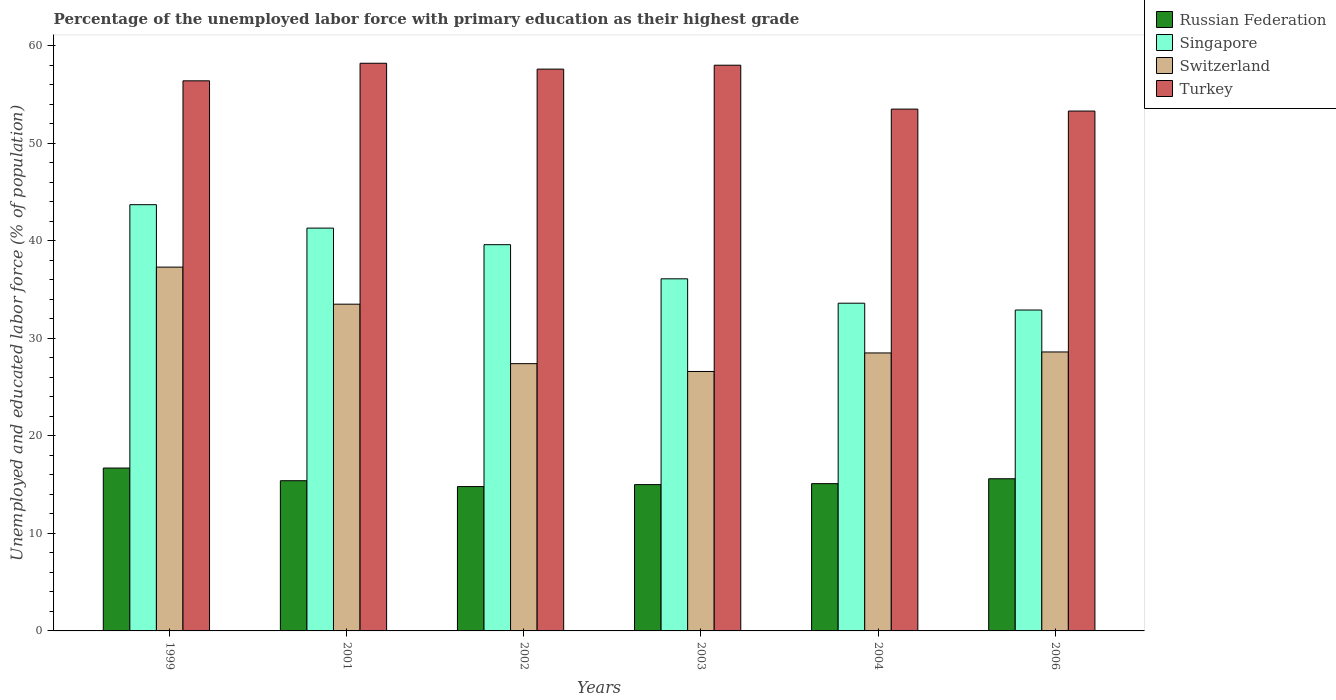How many bars are there on the 2nd tick from the left?
Your answer should be compact. 4. How many bars are there on the 3rd tick from the right?
Make the answer very short. 4. What is the percentage of the unemployed labor force with primary education in Russian Federation in 2001?
Offer a terse response. 15.4. Across all years, what is the maximum percentage of the unemployed labor force with primary education in Russian Federation?
Provide a short and direct response. 16.7. Across all years, what is the minimum percentage of the unemployed labor force with primary education in Switzerland?
Provide a succinct answer. 26.6. In which year was the percentage of the unemployed labor force with primary education in Switzerland maximum?
Your response must be concise. 1999. In which year was the percentage of the unemployed labor force with primary education in Singapore minimum?
Give a very brief answer. 2006. What is the total percentage of the unemployed labor force with primary education in Russian Federation in the graph?
Keep it short and to the point. 92.6. What is the difference between the percentage of the unemployed labor force with primary education in Turkey in 2001 and that in 2004?
Give a very brief answer. 4.7. What is the difference between the percentage of the unemployed labor force with primary education in Russian Federation in 2001 and the percentage of the unemployed labor force with primary education in Turkey in 2006?
Keep it short and to the point. -37.9. What is the average percentage of the unemployed labor force with primary education in Switzerland per year?
Provide a short and direct response. 30.32. In the year 2001, what is the difference between the percentage of the unemployed labor force with primary education in Russian Federation and percentage of the unemployed labor force with primary education in Turkey?
Make the answer very short. -42.8. In how many years, is the percentage of the unemployed labor force with primary education in Singapore greater than 50 %?
Provide a succinct answer. 0. What is the ratio of the percentage of the unemployed labor force with primary education in Turkey in 1999 to that in 2001?
Offer a very short reply. 0.97. Is the difference between the percentage of the unemployed labor force with primary education in Russian Federation in 2002 and 2003 greater than the difference between the percentage of the unemployed labor force with primary education in Turkey in 2002 and 2003?
Give a very brief answer. Yes. What is the difference between the highest and the second highest percentage of the unemployed labor force with primary education in Russian Federation?
Your answer should be compact. 1.1. What is the difference between the highest and the lowest percentage of the unemployed labor force with primary education in Turkey?
Offer a terse response. 4.9. In how many years, is the percentage of the unemployed labor force with primary education in Russian Federation greater than the average percentage of the unemployed labor force with primary education in Russian Federation taken over all years?
Provide a succinct answer. 2. Is the sum of the percentage of the unemployed labor force with primary education in Singapore in 2001 and 2002 greater than the maximum percentage of the unemployed labor force with primary education in Turkey across all years?
Provide a short and direct response. Yes. What does the 1st bar from the left in 2001 represents?
Offer a terse response. Russian Federation. What does the 4th bar from the right in 1999 represents?
Provide a short and direct response. Russian Federation. Is it the case that in every year, the sum of the percentage of the unemployed labor force with primary education in Russian Federation and percentage of the unemployed labor force with primary education in Switzerland is greater than the percentage of the unemployed labor force with primary education in Turkey?
Provide a succinct answer. No. How many bars are there?
Provide a succinct answer. 24. Are all the bars in the graph horizontal?
Provide a succinct answer. No. How many years are there in the graph?
Ensure brevity in your answer.  6. Does the graph contain grids?
Your answer should be very brief. No. Where does the legend appear in the graph?
Your answer should be very brief. Top right. How are the legend labels stacked?
Your answer should be very brief. Vertical. What is the title of the graph?
Offer a very short reply. Percentage of the unemployed labor force with primary education as their highest grade. What is the label or title of the X-axis?
Give a very brief answer. Years. What is the label or title of the Y-axis?
Give a very brief answer. Unemployed and educated labor force (% of population). What is the Unemployed and educated labor force (% of population) in Russian Federation in 1999?
Offer a terse response. 16.7. What is the Unemployed and educated labor force (% of population) in Singapore in 1999?
Make the answer very short. 43.7. What is the Unemployed and educated labor force (% of population) of Switzerland in 1999?
Offer a very short reply. 37.3. What is the Unemployed and educated labor force (% of population) of Turkey in 1999?
Keep it short and to the point. 56.4. What is the Unemployed and educated labor force (% of population) in Russian Federation in 2001?
Ensure brevity in your answer.  15.4. What is the Unemployed and educated labor force (% of population) of Singapore in 2001?
Your answer should be very brief. 41.3. What is the Unemployed and educated labor force (% of population) of Switzerland in 2001?
Offer a terse response. 33.5. What is the Unemployed and educated labor force (% of population) of Turkey in 2001?
Ensure brevity in your answer.  58.2. What is the Unemployed and educated labor force (% of population) in Russian Federation in 2002?
Keep it short and to the point. 14.8. What is the Unemployed and educated labor force (% of population) of Singapore in 2002?
Ensure brevity in your answer.  39.6. What is the Unemployed and educated labor force (% of population) in Switzerland in 2002?
Give a very brief answer. 27.4. What is the Unemployed and educated labor force (% of population) in Turkey in 2002?
Offer a terse response. 57.6. What is the Unemployed and educated labor force (% of population) of Russian Federation in 2003?
Keep it short and to the point. 15. What is the Unemployed and educated labor force (% of population) of Singapore in 2003?
Your answer should be compact. 36.1. What is the Unemployed and educated labor force (% of population) in Switzerland in 2003?
Provide a short and direct response. 26.6. What is the Unemployed and educated labor force (% of population) of Russian Federation in 2004?
Offer a very short reply. 15.1. What is the Unemployed and educated labor force (% of population) in Singapore in 2004?
Offer a terse response. 33.6. What is the Unemployed and educated labor force (% of population) of Turkey in 2004?
Make the answer very short. 53.5. What is the Unemployed and educated labor force (% of population) of Russian Federation in 2006?
Your answer should be compact. 15.6. What is the Unemployed and educated labor force (% of population) in Singapore in 2006?
Your answer should be compact. 32.9. What is the Unemployed and educated labor force (% of population) of Switzerland in 2006?
Your response must be concise. 28.6. What is the Unemployed and educated labor force (% of population) of Turkey in 2006?
Provide a succinct answer. 53.3. Across all years, what is the maximum Unemployed and educated labor force (% of population) of Russian Federation?
Provide a succinct answer. 16.7. Across all years, what is the maximum Unemployed and educated labor force (% of population) of Singapore?
Ensure brevity in your answer.  43.7. Across all years, what is the maximum Unemployed and educated labor force (% of population) of Switzerland?
Provide a short and direct response. 37.3. Across all years, what is the maximum Unemployed and educated labor force (% of population) of Turkey?
Offer a very short reply. 58.2. Across all years, what is the minimum Unemployed and educated labor force (% of population) of Russian Federation?
Your answer should be compact. 14.8. Across all years, what is the minimum Unemployed and educated labor force (% of population) in Singapore?
Provide a succinct answer. 32.9. Across all years, what is the minimum Unemployed and educated labor force (% of population) of Switzerland?
Give a very brief answer. 26.6. Across all years, what is the minimum Unemployed and educated labor force (% of population) in Turkey?
Offer a very short reply. 53.3. What is the total Unemployed and educated labor force (% of population) in Russian Federation in the graph?
Provide a succinct answer. 92.6. What is the total Unemployed and educated labor force (% of population) of Singapore in the graph?
Provide a succinct answer. 227.2. What is the total Unemployed and educated labor force (% of population) in Switzerland in the graph?
Keep it short and to the point. 181.9. What is the total Unemployed and educated labor force (% of population) in Turkey in the graph?
Make the answer very short. 337. What is the difference between the Unemployed and educated labor force (% of population) of Russian Federation in 1999 and that in 2001?
Keep it short and to the point. 1.3. What is the difference between the Unemployed and educated labor force (% of population) of Singapore in 1999 and that in 2001?
Make the answer very short. 2.4. What is the difference between the Unemployed and educated labor force (% of population) in Switzerland in 1999 and that in 2001?
Offer a terse response. 3.8. What is the difference between the Unemployed and educated labor force (% of population) in Turkey in 1999 and that in 2001?
Your answer should be compact. -1.8. What is the difference between the Unemployed and educated labor force (% of population) in Russian Federation in 1999 and that in 2002?
Ensure brevity in your answer.  1.9. What is the difference between the Unemployed and educated labor force (% of population) of Turkey in 1999 and that in 2002?
Make the answer very short. -1.2. What is the difference between the Unemployed and educated labor force (% of population) in Singapore in 1999 and that in 2003?
Your answer should be compact. 7.6. What is the difference between the Unemployed and educated labor force (% of population) in Turkey in 1999 and that in 2003?
Your response must be concise. -1.6. What is the difference between the Unemployed and educated labor force (% of population) in Switzerland in 1999 and that in 2004?
Ensure brevity in your answer.  8.8. What is the difference between the Unemployed and educated labor force (% of population) in Russian Federation in 1999 and that in 2006?
Keep it short and to the point. 1.1. What is the difference between the Unemployed and educated labor force (% of population) of Singapore in 1999 and that in 2006?
Provide a succinct answer. 10.8. What is the difference between the Unemployed and educated labor force (% of population) of Switzerland in 1999 and that in 2006?
Provide a short and direct response. 8.7. What is the difference between the Unemployed and educated labor force (% of population) of Turkey in 1999 and that in 2006?
Your response must be concise. 3.1. What is the difference between the Unemployed and educated labor force (% of population) of Russian Federation in 2001 and that in 2002?
Keep it short and to the point. 0.6. What is the difference between the Unemployed and educated labor force (% of population) in Singapore in 2001 and that in 2002?
Your response must be concise. 1.7. What is the difference between the Unemployed and educated labor force (% of population) in Russian Federation in 2001 and that in 2003?
Give a very brief answer. 0.4. What is the difference between the Unemployed and educated labor force (% of population) of Switzerland in 2001 and that in 2003?
Make the answer very short. 6.9. What is the difference between the Unemployed and educated labor force (% of population) of Russian Federation in 2001 and that in 2004?
Ensure brevity in your answer.  0.3. What is the difference between the Unemployed and educated labor force (% of population) in Singapore in 2001 and that in 2004?
Offer a terse response. 7.7. What is the difference between the Unemployed and educated labor force (% of population) in Switzerland in 2001 and that in 2004?
Your response must be concise. 5. What is the difference between the Unemployed and educated labor force (% of population) in Russian Federation in 2001 and that in 2006?
Give a very brief answer. -0.2. What is the difference between the Unemployed and educated labor force (% of population) of Singapore in 2001 and that in 2006?
Your response must be concise. 8.4. What is the difference between the Unemployed and educated labor force (% of population) in Turkey in 2001 and that in 2006?
Offer a terse response. 4.9. What is the difference between the Unemployed and educated labor force (% of population) of Russian Federation in 2002 and that in 2003?
Your answer should be very brief. -0.2. What is the difference between the Unemployed and educated labor force (% of population) of Singapore in 2002 and that in 2003?
Offer a very short reply. 3.5. What is the difference between the Unemployed and educated labor force (% of population) of Switzerland in 2002 and that in 2003?
Offer a very short reply. 0.8. What is the difference between the Unemployed and educated labor force (% of population) of Turkey in 2002 and that in 2003?
Provide a succinct answer. -0.4. What is the difference between the Unemployed and educated labor force (% of population) of Russian Federation in 2002 and that in 2004?
Give a very brief answer. -0.3. What is the difference between the Unemployed and educated labor force (% of population) of Singapore in 2002 and that in 2004?
Provide a short and direct response. 6. What is the difference between the Unemployed and educated labor force (% of population) of Switzerland in 2002 and that in 2004?
Your answer should be very brief. -1.1. What is the difference between the Unemployed and educated labor force (% of population) in Turkey in 2002 and that in 2004?
Offer a very short reply. 4.1. What is the difference between the Unemployed and educated labor force (% of population) in Russian Federation in 2002 and that in 2006?
Your response must be concise. -0.8. What is the difference between the Unemployed and educated labor force (% of population) of Singapore in 2002 and that in 2006?
Give a very brief answer. 6.7. What is the difference between the Unemployed and educated labor force (% of population) of Russian Federation in 2003 and that in 2004?
Make the answer very short. -0.1. What is the difference between the Unemployed and educated labor force (% of population) of Singapore in 2003 and that in 2004?
Provide a succinct answer. 2.5. What is the difference between the Unemployed and educated labor force (% of population) in Switzerland in 2003 and that in 2004?
Keep it short and to the point. -1.9. What is the difference between the Unemployed and educated labor force (% of population) of Turkey in 2003 and that in 2004?
Your answer should be very brief. 4.5. What is the difference between the Unemployed and educated labor force (% of population) of Russian Federation in 2003 and that in 2006?
Give a very brief answer. -0.6. What is the difference between the Unemployed and educated labor force (% of population) of Switzerland in 2003 and that in 2006?
Ensure brevity in your answer.  -2. What is the difference between the Unemployed and educated labor force (% of population) in Switzerland in 2004 and that in 2006?
Ensure brevity in your answer.  -0.1. What is the difference between the Unemployed and educated labor force (% of population) of Russian Federation in 1999 and the Unemployed and educated labor force (% of population) of Singapore in 2001?
Keep it short and to the point. -24.6. What is the difference between the Unemployed and educated labor force (% of population) in Russian Federation in 1999 and the Unemployed and educated labor force (% of population) in Switzerland in 2001?
Keep it short and to the point. -16.8. What is the difference between the Unemployed and educated labor force (% of population) of Russian Federation in 1999 and the Unemployed and educated labor force (% of population) of Turkey in 2001?
Ensure brevity in your answer.  -41.5. What is the difference between the Unemployed and educated labor force (% of population) of Singapore in 1999 and the Unemployed and educated labor force (% of population) of Switzerland in 2001?
Ensure brevity in your answer.  10.2. What is the difference between the Unemployed and educated labor force (% of population) of Switzerland in 1999 and the Unemployed and educated labor force (% of population) of Turkey in 2001?
Your response must be concise. -20.9. What is the difference between the Unemployed and educated labor force (% of population) of Russian Federation in 1999 and the Unemployed and educated labor force (% of population) of Singapore in 2002?
Your answer should be compact. -22.9. What is the difference between the Unemployed and educated labor force (% of population) of Russian Federation in 1999 and the Unemployed and educated labor force (% of population) of Switzerland in 2002?
Keep it short and to the point. -10.7. What is the difference between the Unemployed and educated labor force (% of population) in Russian Federation in 1999 and the Unemployed and educated labor force (% of population) in Turkey in 2002?
Give a very brief answer. -40.9. What is the difference between the Unemployed and educated labor force (% of population) of Switzerland in 1999 and the Unemployed and educated labor force (% of population) of Turkey in 2002?
Provide a succinct answer. -20.3. What is the difference between the Unemployed and educated labor force (% of population) in Russian Federation in 1999 and the Unemployed and educated labor force (% of population) in Singapore in 2003?
Your answer should be compact. -19.4. What is the difference between the Unemployed and educated labor force (% of population) of Russian Federation in 1999 and the Unemployed and educated labor force (% of population) of Switzerland in 2003?
Make the answer very short. -9.9. What is the difference between the Unemployed and educated labor force (% of population) of Russian Federation in 1999 and the Unemployed and educated labor force (% of population) of Turkey in 2003?
Give a very brief answer. -41.3. What is the difference between the Unemployed and educated labor force (% of population) in Singapore in 1999 and the Unemployed and educated labor force (% of population) in Switzerland in 2003?
Your response must be concise. 17.1. What is the difference between the Unemployed and educated labor force (% of population) in Singapore in 1999 and the Unemployed and educated labor force (% of population) in Turkey in 2003?
Keep it short and to the point. -14.3. What is the difference between the Unemployed and educated labor force (% of population) of Switzerland in 1999 and the Unemployed and educated labor force (% of population) of Turkey in 2003?
Provide a succinct answer. -20.7. What is the difference between the Unemployed and educated labor force (% of population) of Russian Federation in 1999 and the Unemployed and educated labor force (% of population) of Singapore in 2004?
Give a very brief answer. -16.9. What is the difference between the Unemployed and educated labor force (% of population) of Russian Federation in 1999 and the Unemployed and educated labor force (% of population) of Turkey in 2004?
Your answer should be compact. -36.8. What is the difference between the Unemployed and educated labor force (% of population) of Singapore in 1999 and the Unemployed and educated labor force (% of population) of Switzerland in 2004?
Provide a short and direct response. 15.2. What is the difference between the Unemployed and educated labor force (% of population) in Singapore in 1999 and the Unemployed and educated labor force (% of population) in Turkey in 2004?
Offer a terse response. -9.8. What is the difference between the Unemployed and educated labor force (% of population) of Switzerland in 1999 and the Unemployed and educated labor force (% of population) of Turkey in 2004?
Your response must be concise. -16.2. What is the difference between the Unemployed and educated labor force (% of population) of Russian Federation in 1999 and the Unemployed and educated labor force (% of population) of Singapore in 2006?
Your response must be concise. -16.2. What is the difference between the Unemployed and educated labor force (% of population) of Russian Federation in 1999 and the Unemployed and educated labor force (% of population) of Turkey in 2006?
Ensure brevity in your answer.  -36.6. What is the difference between the Unemployed and educated labor force (% of population) of Singapore in 1999 and the Unemployed and educated labor force (% of population) of Switzerland in 2006?
Give a very brief answer. 15.1. What is the difference between the Unemployed and educated labor force (% of population) of Singapore in 1999 and the Unemployed and educated labor force (% of population) of Turkey in 2006?
Provide a short and direct response. -9.6. What is the difference between the Unemployed and educated labor force (% of population) in Switzerland in 1999 and the Unemployed and educated labor force (% of population) in Turkey in 2006?
Make the answer very short. -16. What is the difference between the Unemployed and educated labor force (% of population) in Russian Federation in 2001 and the Unemployed and educated labor force (% of population) in Singapore in 2002?
Your answer should be very brief. -24.2. What is the difference between the Unemployed and educated labor force (% of population) in Russian Federation in 2001 and the Unemployed and educated labor force (% of population) in Switzerland in 2002?
Offer a terse response. -12. What is the difference between the Unemployed and educated labor force (% of population) in Russian Federation in 2001 and the Unemployed and educated labor force (% of population) in Turkey in 2002?
Your response must be concise. -42.2. What is the difference between the Unemployed and educated labor force (% of population) of Singapore in 2001 and the Unemployed and educated labor force (% of population) of Turkey in 2002?
Make the answer very short. -16.3. What is the difference between the Unemployed and educated labor force (% of population) of Switzerland in 2001 and the Unemployed and educated labor force (% of population) of Turkey in 2002?
Provide a short and direct response. -24.1. What is the difference between the Unemployed and educated labor force (% of population) of Russian Federation in 2001 and the Unemployed and educated labor force (% of population) of Singapore in 2003?
Give a very brief answer. -20.7. What is the difference between the Unemployed and educated labor force (% of population) of Russian Federation in 2001 and the Unemployed and educated labor force (% of population) of Switzerland in 2003?
Offer a very short reply. -11.2. What is the difference between the Unemployed and educated labor force (% of population) in Russian Federation in 2001 and the Unemployed and educated labor force (% of population) in Turkey in 2003?
Your answer should be compact. -42.6. What is the difference between the Unemployed and educated labor force (% of population) in Singapore in 2001 and the Unemployed and educated labor force (% of population) in Switzerland in 2003?
Offer a terse response. 14.7. What is the difference between the Unemployed and educated labor force (% of population) in Singapore in 2001 and the Unemployed and educated labor force (% of population) in Turkey in 2003?
Your answer should be compact. -16.7. What is the difference between the Unemployed and educated labor force (% of population) of Switzerland in 2001 and the Unemployed and educated labor force (% of population) of Turkey in 2003?
Ensure brevity in your answer.  -24.5. What is the difference between the Unemployed and educated labor force (% of population) of Russian Federation in 2001 and the Unemployed and educated labor force (% of population) of Singapore in 2004?
Make the answer very short. -18.2. What is the difference between the Unemployed and educated labor force (% of population) of Russian Federation in 2001 and the Unemployed and educated labor force (% of population) of Switzerland in 2004?
Make the answer very short. -13.1. What is the difference between the Unemployed and educated labor force (% of population) of Russian Federation in 2001 and the Unemployed and educated labor force (% of population) of Turkey in 2004?
Your response must be concise. -38.1. What is the difference between the Unemployed and educated labor force (% of population) in Switzerland in 2001 and the Unemployed and educated labor force (% of population) in Turkey in 2004?
Ensure brevity in your answer.  -20. What is the difference between the Unemployed and educated labor force (% of population) of Russian Federation in 2001 and the Unemployed and educated labor force (% of population) of Singapore in 2006?
Provide a succinct answer. -17.5. What is the difference between the Unemployed and educated labor force (% of population) in Russian Federation in 2001 and the Unemployed and educated labor force (% of population) in Switzerland in 2006?
Provide a succinct answer. -13.2. What is the difference between the Unemployed and educated labor force (% of population) in Russian Federation in 2001 and the Unemployed and educated labor force (% of population) in Turkey in 2006?
Keep it short and to the point. -37.9. What is the difference between the Unemployed and educated labor force (% of population) of Singapore in 2001 and the Unemployed and educated labor force (% of population) of Switzerland in 2006?
Offer a very short reply. 12.7. What is the difference between the Unemployed and educated labor force (% of population) of Switzerland in 2001 and the Unemployed and educated labor force (% of population) of Turkey in 2006?
Provide a succinct answer. -19.8. What is the difference between the Unemployed and educated labor force (% of population) in Russian Federation in 2002 and the Unemployed and educated labor force (% of population) in Singapore in 2003?
Provide a short and direct response. -21.3. What is the difference between the Unemployed and educated labor force (% of population) of Russian Federation in 2002 and the Unemployed and educated labor force (% of population) of Switzerland in 2003?
Ensure brevity in your answer.  -11.8. What is the difference between the Unemployed and educated labor force (% of population) of Russian Federation in 2002 and the Unemployed and educated labor force (% of population) of Turkey in 2003?
Your answer should be very brief. -43.2. What is the difference between the Unemployed and educated labor force (% of population) of Singapore in 2002 and the Unemployed and educated labor force (% of population) of Switzerland in 2003?
Provide a short and direct response. 13. What is the difference between the Unemployed and educated labor force (% of population) of Singapore in 2002 and the Unemployed and educated labor force (% of population) of Turkey in 2003?
Keep it short and to the point. -18.4. What is the difference between the Unemployed and educated labor force (% of population) of Switzerland in 2002 and the Unemployed and educated labor force (% of population) of Turkey in 2003?
Give a very brief answer. -30.6. What is the difference between the Unemployed and educated labor force (% of population) in Russian Federation in 2002 and the Unemployed and educated labor force (% of population) in Singapore in 2004?
Keep it short and to the point. -18.8. What is the difference between the Unemployed and educated labor force (% of population) of Russian Federation in 2002 and the Unemployed and educated labor force (% of population) of Switzerland in 2004?
Your answer should be very brief. -13.7. What is the difference between the Unemployed and educated labor force (% of population) in Russian Federation in 2002 and the Unemployed and educated labor force (% of population) in Turkey in 2004?
Make the answer very short. -38.7. What is the difference between the Unemployed and educated labor force (% of population) of Singapore in 2002 and the Unemployed and educated labor force (% of population) of Switzerland in 2004?
Provide a succinct answer. 11.1. What is the difference between the Unemployed and educated labor force (% of population) of Singapore in 2002 and the Unemployed and educated labor force (% of population) of Turkey in 2004?
Make the answer very short. -13.9. What is the difference between the Unemployed and educated labor force (% of population) of Switzerland in 2002 and the Unemployed and educated labor force (% of population) of Turkey in 2004?
Offer a terse response. -26.1. What is the difference between the Unemployed and educated labor force (% of population) of Russian Federation in 2002 and the Unemployed and educated labor force (% of population) of Singapore in 2006?
Offer a very short reply. -18.1. What is the difference between the Unemployed and educated labor force (% of population) in Russian Federation in 2002 and the Unemployed and educated labor force (% of population) in Turkey in 2006?
Offer a terse response. -38.5. What is the difference between the Unemployed and educated labor force (% of population) in Singapore in 2002 and the Unemployed and educated labor force (% of population) in Switzerland in 2006?
Give a very brief answer. 11. What is the difference between the Unemployed and educated labor force (% of population) in Singapore in 2002 and the Unemployed and educated labor force (% of population) in Turkey in 2006?
Ensure brevity in your answer.  -13.7. What is the difference between the Unemployed and educated labor force (% of population) of Switzerland in 2002 and the Unemployed and educated labor force (% of population) of Turkey in 2006?
Provide a short and direct response. -25.9. What is the difference between the Unemployed and educated labor force (% of population) in Russian Federation in 2003 and the Unemployed and educated labor force (% of population) in Singapore in 2004?
Provide a succinct answer. -18.6. What is the difference between the Unemployed and educated labor force (% of population) of Russian Federation in 2003 and the Unemployed and educated labor force (% of population) of Switzerland in 2004?
Make the answer very short. -13.5. What is the difference between the Unemployed and educated labor force (% of population) of Russian Federation in 2003 and the Unemployed and educated labor force (% of population) of Turkey in 2004?
Make the answer very short. -38.5. What is the difference between the Unemployed and educated labor force (% of population) in Singapore in 2003 and the Unemployed and educated labor force (% of population) in Switzerland in 2004?
Give a very brief answer. 7.6. What is the difference between the Unemployed and educated labor force (% of population) in Singapore in 2003 and the Unemployed and educated labor force (% of population) in Turkey in 2004?
Your response must be concise. -17.4. What is the difference between the Unemployed and educated labor force (% of population) in Switzerland in 2003 and the Unemployed and educated labor force (% of population) in Turkey in 2004?
Give a very brief answer. -26.9. What is the difference between the Unemployed and educated labor force (% of population) in Russian Federation in 2003 and the Unemployed and educated labor force (% of population) in Singapore in 2006?
Make the answer very short. -17.9. What is the difference between the Unemployed and educated labor force (% of population) in Russian Federation in 2003 and the Unemployed and educated labor force (% of population) in Switzerland in 2006?
Give a very brief answer. -13.6. What is the difference between the Unemployed and educated labor force (% of population) of Russian Federation in 2003 and the Unemployed and educated labor force (% of population) of Turkey in 2006?
Offer a very short reply. -38.3. What is the difference between the Unemployed and educated labor force (% of population) in Singapore in 2003 and the Unemployed and educated labor force (% of population) in Switzerland in 2006?
Your answer should be compact. 7.5. What is the difference between the Unemployed and educated labor force (% of population) of Singapore in 2003 and the Unemployed and educated labor force (% of population) of Turkey in 2006?
Give a very brief answer. -17.2. What is the difference between the Unemployed and educated labor force (% of population) of Switzerland in 2003 and the Unemployed and educated labor force (% of population) of Turkey in 2006?
Make the answer very short. -26.7. What is the difference between the Unemployed and educated labor force (% of population) in Russian Federation in 2004 and the Unemployed and educated labor force (% of population) in Singapore in 2006?
Provide a short and direct response. -17.8. What is the difference between the Unemployed and educated labor force (% of population) in Russian Federation in 2004 and the Unemployed and educated labor force (% of population) in Switzerland in 2006?
Offer a very short reply. -13.5. What is the difference between the Unemployed and educated labor force (% of population) in Russian Federation in 2004 and the Unemployed and educated labor force (% of population) in Turkey in 2006?
Offer a terse response. -38.2. What is the difference between the Unemployed and educated labor force (% of population) of Singapore in 2004 and the Unemployed and educated labor force (% of population) of Turkey in 2006?
Provide a succinct answer. -19.7. What is the difference between the Unemployed and educated labor force (% of population) of Switzerland in 2004 and the Unemployed and educated labor force (% of population) of Turkey in 2006?
Keep it short and to the point. -24.8. What is the average Unemployed and educated labor force (% of population) of Russian Federation per year?
Provide a short and direct response. 15.43. What is the average Unemployed and educated labor force (% of population) in Singapore per year?
Offer a terse response. 37.87. What is the average Unemployed and educated labor force (% of population) in Switzerland per year?
Your answer should be very brief. 30.32. What is the average Unemployed and educated labor force (% of population) of Turkey per year?
Keep it short and to the point. 56.17. In the year 1999, what is the difference between the Unemployed and educated labor force (% of population) in Russian Federation and Unemployed and educated labor force (% of population) in Singapore?
Make the answer very short. -27. In the year 1999, what is the difference between the Unemployed and educated labor force (% of population) in Russian Federation and Unemployed and educated labor force (% of population) in Switzerland?
Keep it short and to the point. -20.6. In the year 1999, what is the difference between the Unemployed and educated labor force (% of population) of Russian Federation and Unemployed and educated labor force (% of population) of Turkey?
Provide a succinct answer. -39.7. In the year 1999, what is the difference between the Unemployed and educated labor force (% of population) of Switzerland and Unemployed and educated labor force (% of population) of Turkey?
Offer a terse response. -19.1. In the year 2001, what is the difference between the Unemployed and educated labor force (% of population) of Russian Federation and Unemployed and educated labor force (% of population) of Singapore?
Offer a very short reply. -25.9. In the year 2001, what is the difference between the Unemployed and educated labor force (% of population) in Russian Federation and Unemployed and educated labor force (% of population) in Switzerland?
Offer a very short reply. -18.1. In the year 2001, what is the difference between the Unemployed and educated labor force (% of population) in Russian Federation and Unemployed and educated labor force (% of population) in Turkey?
Ensure brevity in your answer.  -42.8. In the year 2001, what is the difference between the Unemployed and educated labor force (% of population) in Singapore and Unemployed and educated labor force (% of population) in Turkey?
Your response must be concise. -16.9. In the year 2001, what is the difference between the Unemployed and educated labor force (% of population) of Switzerland and Unemployed and educated labor force (% of population) of Turkey?
Provide a short and direct response. -24.7. In the year 2002, what is the difference between the Unemployed and educated labor force (% of population) of Russian Federation and Unemployed and educated labor force (% of population) of Singapore?
Make the answer very short. -24.8. In the year 2002, what is the difference between the Unemployed and educated labor force (% of population) of Russian Federation and Unemployed and educated labor force (% of population) of Switzerland?
Provide a succinct answer. -12.6. In the year 2002, what is the difference between the Unemployed and educated labor force (% of population) of Russian Federation and Unemployed and educated labor force (% of population) of Turkey?
Make the answer very short. -42.8. In the year 2002, what is the difference between the Unemployed and educated labor force (% of population) in Singapore and Unemployed and educated labor force (% of population) in Turkey?
Ensure brevity in your answer.  -18. In the year 2002, what is the difference between the Unemployed and educated labor force (% of population) in Switzerland and Unemployed and educated labor force (% of population) in Turkey?
Provide a succinct answer. -30.2. In the year 2003, what is the difference between the Unemployed and educated labor force (% of population) of Russian Federation and Unemployed and educated labor force (% of population) of Singapore?
Your answer should be very brief. -21.1. In the year 2003, what is the difference between the Unemployed and educated labor force (% of population) in Russian Federation and Unemployed and educated labor force (% of population) in Turkey?
Provide a succinct answer. -43. In the year 2003, what is the difference between the Unemployed and educated labor force (% of population) in Singapore and Unemployed and educated labor force (% of population) in Switzerland?
Provide a short and direct response. 9.5. In the year 2003, what is the difference between the Unemployed and educated labor force (% of population) of Singapore and Unemployed and educated labor force (% of population) of Turkey?
Keep it short and to the point. -21.9. In the year 2003, what is the difference between the Unemployed and educated labor force (% of population) of Switzerland and Unemployed and educated labor force (% of population) of Turkey?
Your answer should be very brief. -31.4. In the year 2004, what is the difference between the Unemployed and educated labor force (% of population) of Russian Federation and Unemployed and educated labor force (% of population) of Singapore?
Ensure brevity in your answer.  -18.5. In the year 2004, what is the difference between the Unemployed and educated labor force (% of population) of Russian Federation and Unemployed and educated labor force (% of population) of Switzerland?
Keep it short and to the point. -13.4. In the year 2004, what is the difference between the Unemployed and educated labor force (% of population) of Russian Federation and Unemployed and educated labor force (% of population) of Turkey?
Give a very brief answer. -38.4. In the year 2004, what is the difference between the Unemployed and educated labor force (% of population) in Singapore and Unemployed and educated labor force (% of population) in Switzerland?
Offer a very short reply. 5.1. In the year 2004, what is the difference between the Unemployed and educated labor force (% of population) in Singapore and Unemployed and educated labor force (% of population) in Turkey?
Provide a succinct answer. -19.9. In the year 2006, what is the difference between the Unemployed and educated labor force (% of population) of Russian Federation and Unemployed and educated labor force (% of population) of Singapore?
Your answer should be very brief. -17.3. In the year 2006, what is the difference between the Unemployed and educated labor force (% of population) in Russian Federation and Unemployed and educated labor force (% of population) in Turkey?
Provide a short and direct response. -37.7. In the year 2006, what is the difference between the Unemployed and educated labor force (% of population) of Singapore and Unemployed and educated labor force (% of population) of Switzerland?
Your answer should be very brief. 4.3. In the year 2006, what is the difference between the Unemployed and educated labor force (% of population) in Singapore and Unemployed and educated labor force (% of population) in Turkey?
Offer a very short reply. -20.4. In the year 2006, what is the difference between the Unemployed and educated labor force (% of population) of Switzerland and Unemployed and educated labor force (% of population) of Turkey?
Your answer should be compact. -24.7. What is the ratio of the Unemployed and educated labor force (% of population) in Russian Federation in 1999 to that in 2001?
Ensure brevity in your answer.  1.08. What is the ratio of the Unemployed and educated labor force (% of population) in Singapore in 1999 to that in 2001?
Provide a short and direct response. 1.06. What is the ratio of the Unemployed and educated labor force (% of population) of Switzerland in 1999 to that in 2001?
Your answer should be very brief. 1.11. What is the ratio of the Unemployed and educated labor force (% of population) in Turkey in 1999 to that in 2001?
Your answer should be compact. 0.97. What is the ratio of the Unemployed and educated labor force (% of population) in Russian Federation in 1999 to that in 2002?
Your answer should be very brief. 1.13. What is the ratio of the Unemployed and educated labor force (% of population) in Singapore in 1999 to that in 2002?
Your answer should be very brief. 1.1. What is the ratio of the Unemployed and educated labor force (% of population) in Switzerland in 1999 to that in 2002?
Your answer should be compact. 1.36. What is the ratio of the Unemployed and educated labor force (% of population) of Turkey in 1999 to that in 2002?
Your answer should be compact. 0.98. What is the ratio of the Unemployed and educated labor force (% of population) in Russian Federation in 1999 to that in 2003?
Keep it short and to the point. 1.11. What is the ratio of the Unemployed and educated labor force (% of population) in Singapore in 1999 to that in 2003?
Your answer should be compact. 1.21. What is the ratio of the Unemployed and educated labor force (% of population) in Switzerland in 1999 to that in 2003?
Your answer should be very brief. 1.4. What is the ratio of the Unemployed and educated labor force (% of population) in Turkey in 1999 to that in 2003?
Give a very brief answer. 0.97. What is the ratio of the Unemployed and educated labor force (% of population) in Russian Federation in 1999 to that in 2004?
Provide a succinct answer. 1.11. What is the ratio of the Unemployed and educated labor force (% of population) in Singapore in 1999 to that in 2004?
Ensure brevity in your answer.  1.3. What is the ratio of the Unemployed and educated labor force (% of population) in Switzerland in 1999 to that in 2004?
Offer a terse response. 1.31. What is the ratio of the Unemployed and educated labor force (% of population) of Turkey in 1999 to that in 2004?
Keep it short and to the point. 1.05. What is the ratio of the Unemployed and educated labor force (% of population) in Russian Federation in 1999 to that in 2006?
Your response must be concise. 1.07. What is the ratio of the Unemployed and educated labor force (% of population) of Singapore in 1999 to that in 2006?
Ensure brevity in your answer.  1.33. What is the ratio of the Unemployed and educated labor force (% of population) of Switzerland in 1999 to that in 2006?
Your answer should be compact. 1.3. What is the ratio of the Unemployed and educated labor force (% of population) in Turkey in 1999 to that in 2006?
Make the answer very short. 1.06. What is the ratio of the Unemployed and educated labor force (% of population) of Russian Federation in 2001 to that in 2002?
Ensure brevity in your answer.  1.04. What is the ratio of the Unemployed and educated labor force (% of population) in Singapore in 2001 to that in 2002?
Make the answer very short. 1.04. What is the ratio of the Unemployed and educated labor force (% of population) in Switzerland in 2001 to that in 2002?
Offer a terse response. 1.22. What is the ratio of the Unemployed and educated labor force (% of population) in Turkey in 2001 to that in 2002?
Give a very brief answer. 1.01. What is the ratio of the Unemployed and educated labor force (% of population) in Russian Federation in 2001 to that in 2003?
Make the answer very short. 1.03. What is the ratio of the Unemployed and educated labor force (% of population) of Singapore in 2001 to that in 2003?
Make the answer very short. 1.14. What is the ratio of the Unemployed and educated labor force (% of population) of Switzerland in 2001 to that in 2003?
Keep it short and to the point. 1.26. What is the ratio of the Unemployed and educated labor force (% of population) in Russian Federation in 2001 to that in 2004?
Your answer should be very brief. 1.02. What is the ratio of the Unemployed and educated labor force (% of population) in Singapore in 2001 to that in 2004?
Make the answer very short. 1.23. What is the ratio of the Unemployed and educated labor force (% of population) in Switzerland in 2001 to that in 2004?
Give a very brief answer. 1.18. What is the ratio of the Unemployed and educated labor force (% of population) of Turkey in 2001 to that in 2004?
Give a very brief answer. 1.09. What is the ratio of the Unemployed and educated labor force (% of population) of Russian Federation in 2001 to that in 2006?
Your answer should be very brief. 0.99. What is the ratio of the Unemployed and educated labor force (% of population) of Singapore in 2001 to that in 2006?
Offer a terse response. 1.26. What is the ratio of the Unemployed and educated labor force (% of population) of Switzerland in 2001 to that in 2006?
Keep it short and to the point. 1.17. What is the ratio of the Unemployed and educated labor force (% of population) of Turkey in 2001 to that in 2006?
Offer a very short reply. 1.09. What is the ratio of the Unemployed and educated labor force (% of population) of Russian Federation in 2002 to that in 2003?
Keep it short and to the point. 0.99. What is the ratio of the Unemployed and educated labor force (% of population) in Singapore in 2002 to that in 2003?
Ensure brevity in your answer.  1.1. What is the ratio of the Unemployed and educated labor force (% of population) in Switzerland in 2002 to that in 2003?
Provide a short and direct response. 1.03. What is the ratio of the Unemployed and educated labor force (% of population) of Turkey in 2002 to that in 2003?
Offer a terse response. 0.99. What is the ratio of the Unemployed and educated labor force (% of population) of Russian Federation in 2002 to that in 2004?
Make the answer very short. 0.98. What is the ratio of the Unemployed and educated labor force (% of population) of Singapore in 2002 to that in 2004?
Provide a succinct answer. 1.18. What is the ratio of the Unemployed and educated labor force (% of population) in Switzerland in 2002 to that in 2004?
Keep it short and to the point. 0.96. What is the ratio of the Unemployed and educated labor force (% of population) in Turkey in 2002 to that in 2004?
Provide a short and direct response. 1.08. What is the ratio of the Unemployed and educated labor force (% of population) of Russian Federation in 2002 to that in 2006?
Offer a terse response. 0.95. What is the ratio of the Unemployed and educated labor force (% of population) of Singapore in 2002 to that in 2006?
Provide a succinct answer. 1.2. What is the ratio of the Unemployed and educated labor force (% of population) in Switzerland in 2002 to that in 2006?
Your answer should be very brief. 0.96. What is the ratio of the Unemployed and educated labor force (% of population) in Turkey in 2002 to that in 2006?
Offer a terse response. 1.08. What is the ratio of the Unemployed and educated labor force (% of population) of Russian Federation in 2003 to that in 2004?
Your response must be concise. 0.99. What is the ratio of the Unemployed and educated labor force (% of population) of Singapore in 2003 to that in 2004?
Your answer should be very brief. 1.07. What is the ratio of the Unemployed and educated labor force (% of population) in Turkey in 2003 to that in 2004?
Your answer should be very brief. 1.08. What is the ratio of the Unemployed and educated labor force (% of population) of Russian Federation in 2003 to that in 2006?
Give a very brief answer. 0.96. What is the ratio of the Unemployed and educated labor force (% of population) of Singapore in 2003 to that in 2006?
Give a very brief answer. 1.1. What is the ratio of the Unemployed and educated labor force (% of population) of Switzerland in 2003 to that in 2006?
Your answer should be compact. 0.93. What is the ratio of the Unemployed and educated labor force (% of population) of Turkey in 2003 to that in 2006?
Offer a very short reply. 1.09. What is the ratio of the Unemployed and educated labor force (% of population) of Russian Federation in 2004 to that in 2006?
Offer a very short reply. 0.97. What is the ratio of the Unemployed and educated labor force (% of population) of Singapore in 2004 to that in 2006?
Your answer should be very brief. 1.02. What is the difference between the highest and the second highest Unemployed and educated labor force (% of population) of Switzerland?
Provide a short and direct response. 3.8. What is the difference between the highest and the lowest Unemployed and educated labor force (% of population) of Russian Federation?
Make the answer very short. 1.9. 